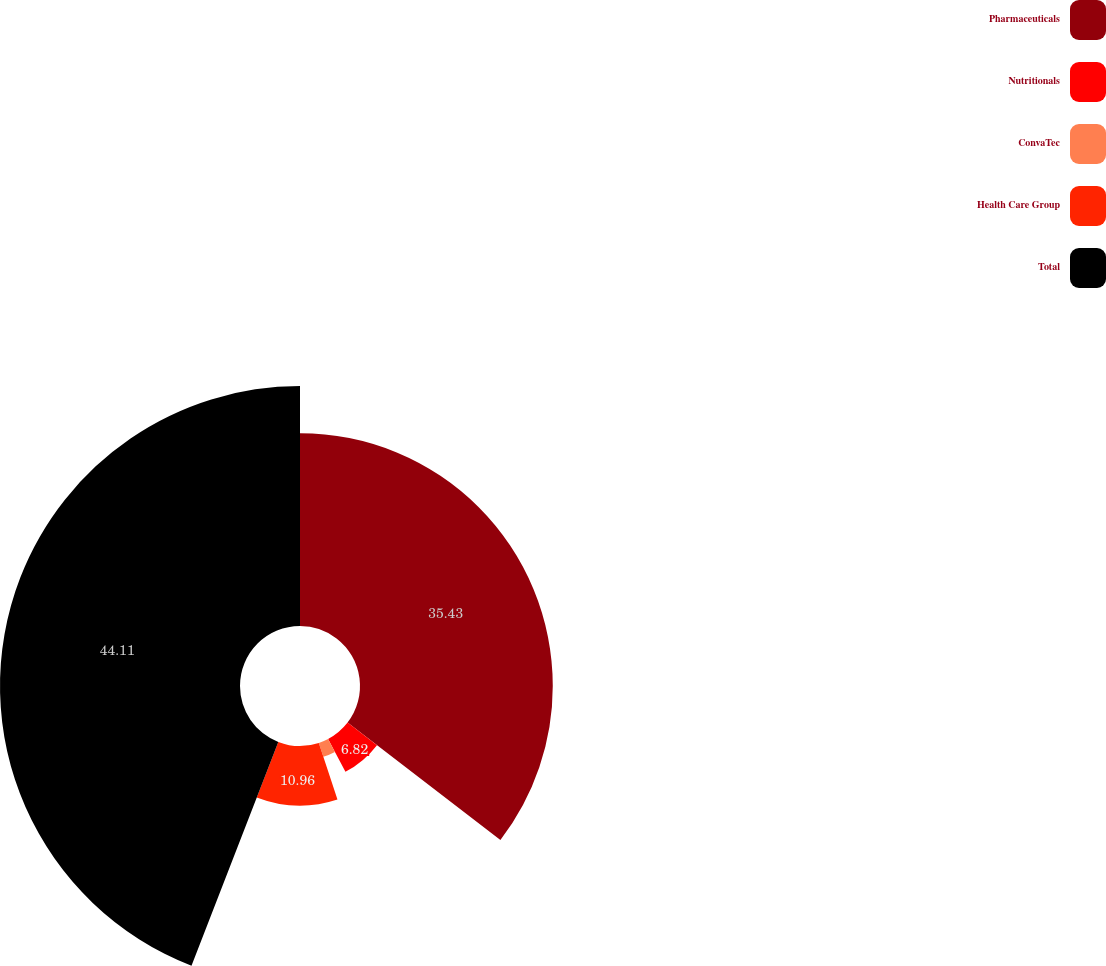<chart> <loc_0><loc_0><loc_500><loc_500><pie_chart><fcel>Pharmaceuticals<fcel>Nutritionals<fcel>ConvaTec<fcel>Health Care Group<fcel>Total<nl><fcel>35.43%<fcel>6.82%<fcel>2.68%<fcel>10.96%<fcel>44.11%<nl></chart> 